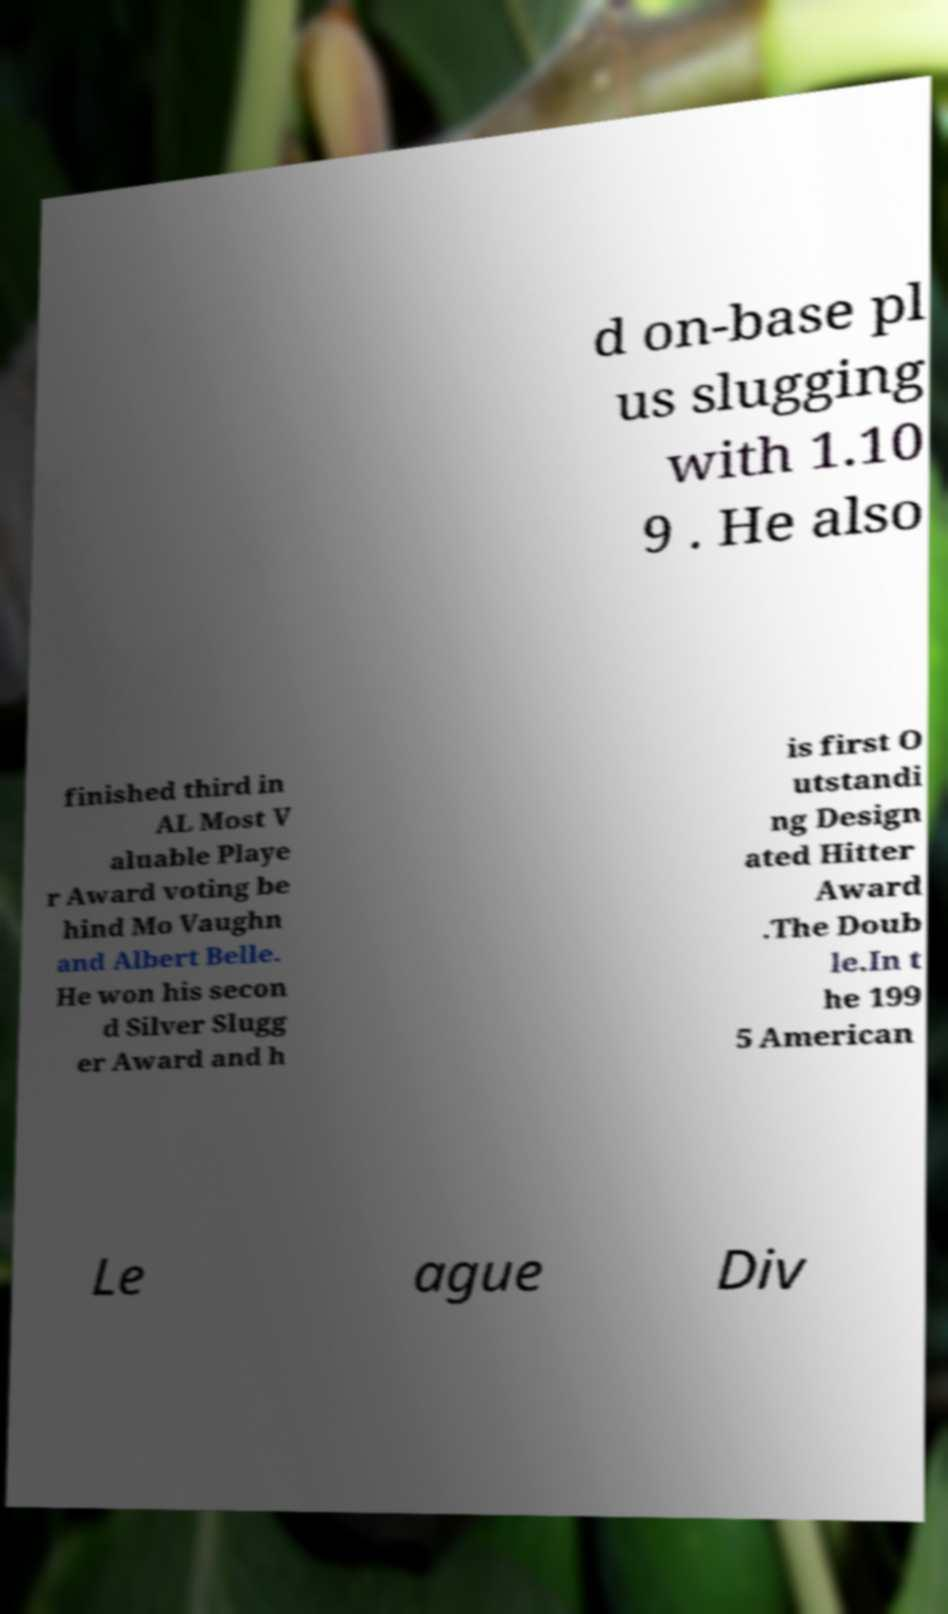I need the written content from this picture converted into text. Can you do that? d on-base pl us slugging with 1.10 9 . He also finished third in AL Most V aluable Playe r Award voting be hind Mo Vaughn and Albert Belle. He won his secon d Silver Slugg er Award and h is first O utstandi ng Design ated Hitter Award .The Doub le.In t he 199 5 American Le ague Div 